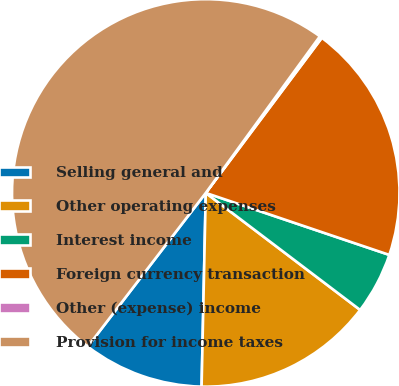<chart> <loc_0><loc_0><loc_500><loc_500><pie_chart><fcel>Selling general and<fcel>Other operating expenses<fcel>Interest income<fcel>Foreign currency transaction<fcel>Other (expense) income<fcel>Provision for income taxes<nl><fcel>10.08%<fcel>15.02%<fcel>5.14%<fcel>19.96%<fcel>0.2%<fcel>49.6%<nl></chart> 